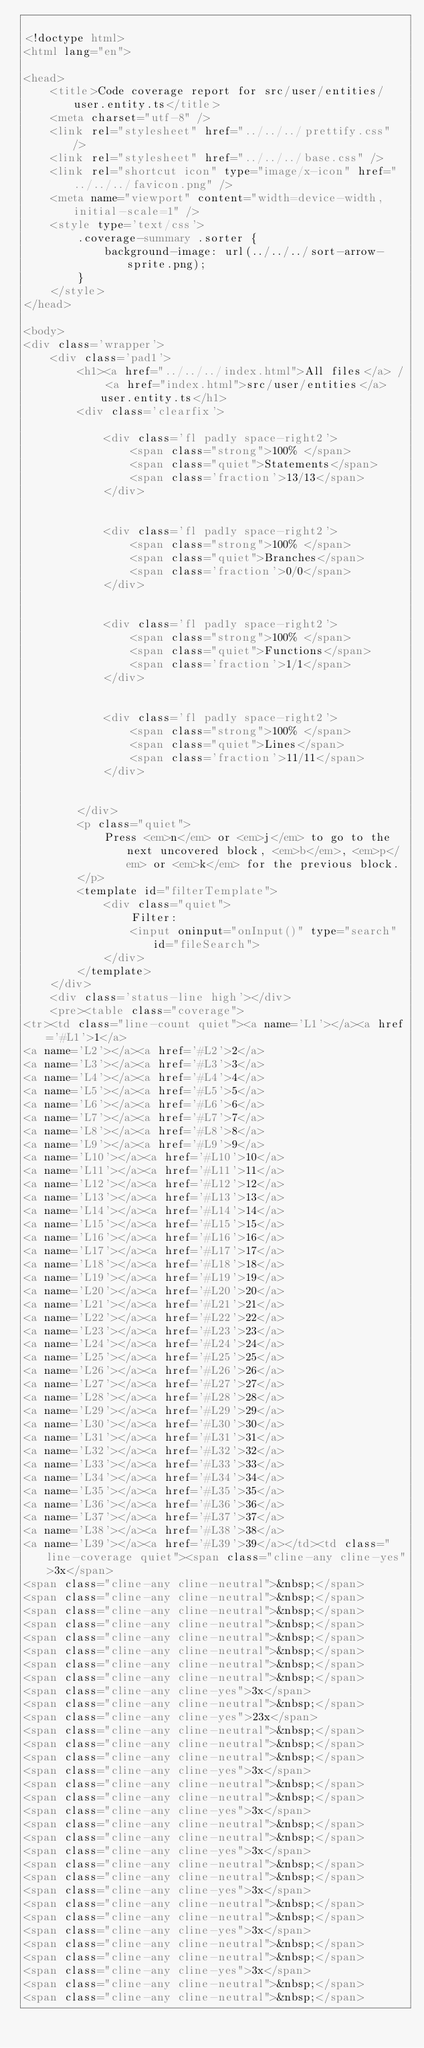<code> <loc_0><loc_0><loc_500><loc_500><_HTML_>
<!doctype html>
<html lang="en">

<head>
    <title>Code coverage report for src/user/entities/user.entity.ts</title>
    <meta charset="utf-8" />
    <link rel="stylesheet" href="../../../prettify.css" />
    <link rel="stylesheet" href="../../../base.css" />
    <link rel="shortcut icon" type="image/x-icon" href="../../../favicon.png" />
    <meta name="viewport" content="width=device-width, initial-scale=1" />
    <style type='text/css'>
        .coverage-summary .sorter {
            background-image: url(../../../sort-arrow-sprite.png);
        }
    </style>
</head>
    
<body>
<div class='wrapper'>
    <div class='pad1'>
        <h1><a href="../../../index.html">All files</a> / <a href="index.html">src/user/entities</a> user.entity.ts</h1>
        <div class='clearfix'>
            
            <div class='fl pad1y space-right2'>
                <span class="strong">100% </span>
                <span class="quiet">Statements</span>
                <span class='fraction'>13/13</span>
            </div>
        
            
            <div class='fl pad1y space-right2'>
                <span class="strong">100% </span>
                <span class="quiet">Branches</span>
                <span class='fraction'>0/0</span>
            </div>
        
            
            <div class='fl pad1y space-right2'>
                <span class="strong">100% </span>
                <span class="quiet">Functions</span>
                <span class='fraction'>1/1</span>
            </div>
        
            
            <div class='fl pad1y space-right2'>
                <span class="strong">100% </span>
                <span class="quiet">Lines</span>
                <span class='fraction'>11/11</span>
            </div>
        
            
        </div>
        <p class="quiet">
            Press <em>n</em> or <em>j</em> to go to the next uncovered block, <em>b</em>, <em>p</em> or <em>k</em> for the previous block.
        </p>
        <template id="filterTemplate">
            <div class="quiet">
                Filter:
                <input oninput="onInput()" type="search" id="fileSearch">
            </div>
        </template>
    </div>
    <div class='status-line high'></div>
    <pre><table class="coverage">
<tr><td class="line-count quiet"><a name='L1'></a><a href='#L1'>1</a>
<a name='L2'></a><a href='#L2'>2</a>
<a name='L3'></a><a href='#L3'>3</a>
<a name='L4'></a><a href='#L4'>4</a>
<a name='L5'></a><a href='#L5'>5</a>
<a name='L6'></a><a href='#L6'>6</a>
<a name='L7'></a><a href='#L7'>7</a>
<a name='L8'></a><a href='#L8'>8</a>
<a name='L9'></a><a href='#L9'>9</a>
<a name='L10'></a><a href='#L10'>10</a>
<a name='L11'></a><a href='#L11'>11</a>
<a name='L12'></a><a href='#L12'>12</a>
<a name='L13'></a><a href='#L13'>13</a>
<a name='L14'></a><a href='#L14'>14</a>
<a name='L15'></a><a href='#L15'>15</a>
<a name='L16'></a><a href='#L16'>16</a>
<a name='L17'></a><a href='#L17'>17</a>
<a name='L18'></a><a href='#L18'>18</a>
<a name='L19'></a><a href='#L19'>19</a>
<a name='L20'></a><a href='#L20'>20</a>
<a name='L21'></a><a href='#L21'>21</a>
<a name='L22'></a><a href='#L22'>22</a>
<a name='L23'></a><a href='#L23'>23</a>
<a name='L24'></a><a href='#L24'>24</a>
<a name='L25'></a><a href='#L25'>25</a>
<a name='L26'></a><a href='#L26'>26</a>
<a name='L27'></a><a href='#L27'>27</a>
<a name='L28'></a><a href='#L28'>28</a>
<a name='L29'></a><a href='#L29'>29</a>
<a name='L30'></a><a href='#L30'>30</a>
<a name='L31'></a><a href='#L31'>31</a>
<a name='L32'></a><a href='#L32'>32</a>
<a name='L33'></a><a href='#L33'>33</a>
<a name='L34'></a><a href='#L34'>34</a>
<a name='L35'></a><a href='#L35'>35</a>
<a name='L36'></a><a href='#L36'>36</a>
<a name='L37'></a><a href='#L37'>37</a>
<a name='L38'></a><a href='#L38'>38</a>
<a name='L39'></a><a href='#L39'>39</a></td><td class="line-coverage quiet"><span class="cline-any cline-yes">3x</span>
<span class="cline-any cline-neutral">&nbsp;</span>
<span class="cline-any cline-neutral">&nbsp;</span>
<span class="cline-any cline-neutral">&nbsp;</span>
<span class="cline-any cline-neutral">&nbsp;</span>
<span class="cline-any cline-neutral">&nbsp;</span>
<span class="cline-any cline-neutral">&nbsp;</span>
<span class="cline-any cline-neutral">&nbsp;</span>
<span class="cline-any cline-neutral">&nbsp;</span>
<span class="cline-any cline-yes">3x</span>
<span class="cline-any cline-neutral">&nbsp;</span>
<span class="cline-any cline-yes">23x</span>
<span class="cline-any cline-neutral">&nbsp;</span>
<span class="cline-any cline-neutral">&nbsp;</span>
<span class="cline-any cline-neutral">&nbsp;</span>
<span class="cline-any cline-yes">3x</span>
<span class="cline-any cline-neutral">&nbsp;</span>
<span class="cline-any cline-neutral">&nbsp;</span>
<span class="cline-any cline-yes">3x</span>
<span class="cline-any cline-neutral">&nbsp;</span>
<span class="cline-any cline-neutral">&nbsp;</span>
<span class="cline-any cline-yes">3x</span>
<span class="cline-any cline-neutral">&nbsp;</span>
<span class="cline-any cline-neutral">&nbsp;</span>
<span class="cline-any cline-yes">3x</span>
<span class="cline-any cline-neutral">&nbsp;</span>
<span class="cline-any cline-neutral">&nbsp;</span>
<span class="cline-any cline-yes">3x</span>
<span class="cline-any cline-neutral">&nbsp;</span>
<span class="cline-any cline-neutral">&nbsp;</span>
<span class="cline-any cline-yes">3x</span>
<span class="cline-any cline-neutral">&nbsp;</span>
<span class="cline-any cline-neutral">&nbsp;</span></code> 